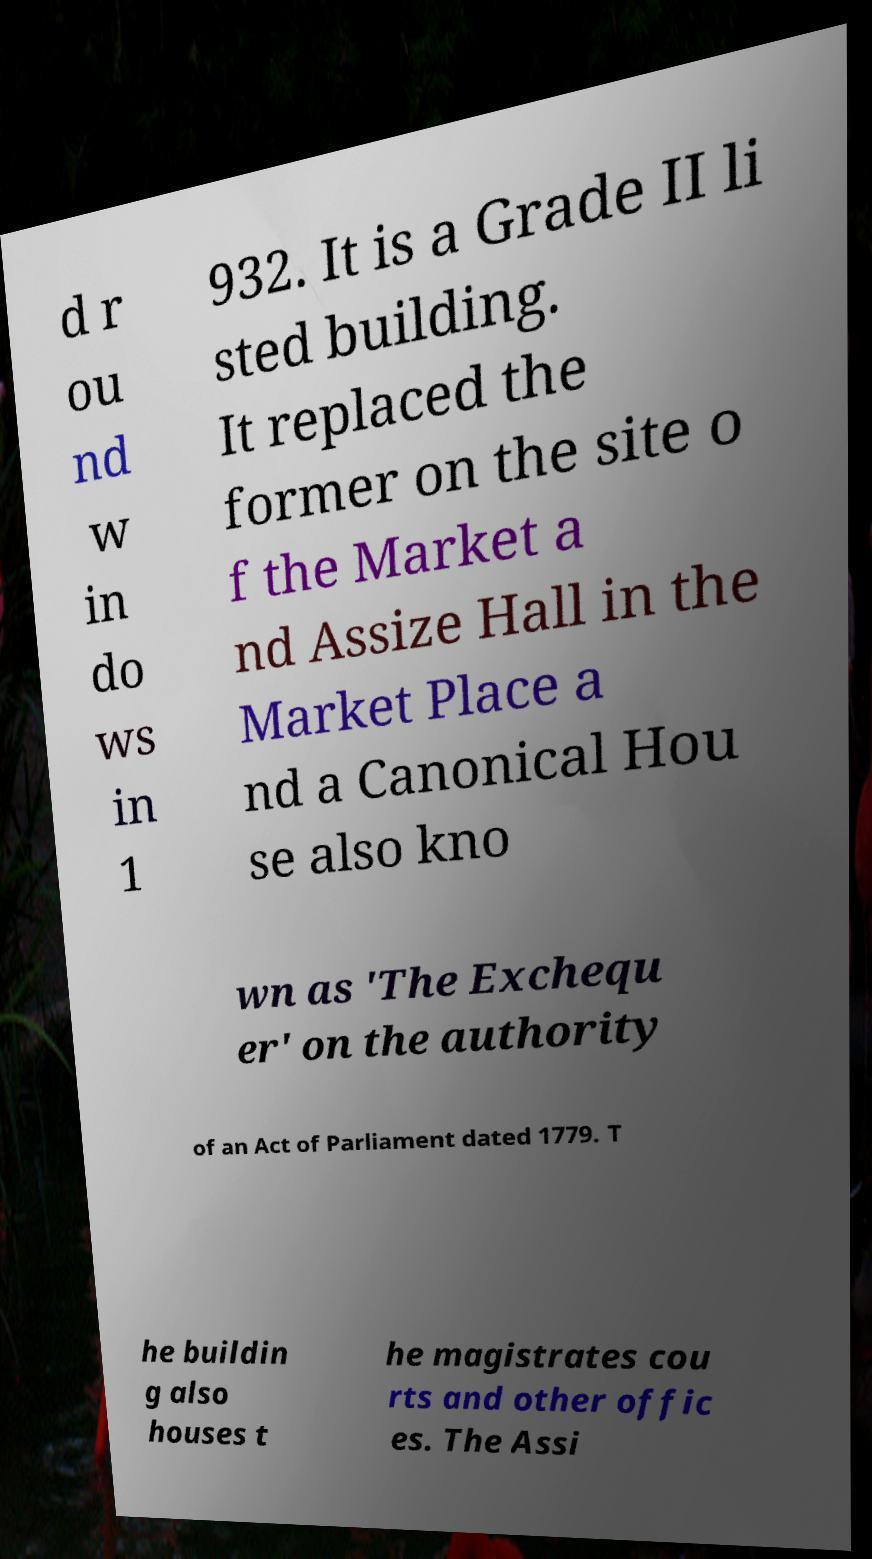For documentation purposes, I need the text within this image transcribed. Could you provide that? d r ou nd w in do ws in 1 932. It is a Grade II li sted building. It replaced the former on the site o f the Market a nd Assize Hall in the Market Place a nd a Canonical Hou se also kno wn as 'The Exchequ er' on the authority of an Act of Parliament dated 1779. T he buildin g also houses t he magistrates cou rts and other offic es. The Assi 